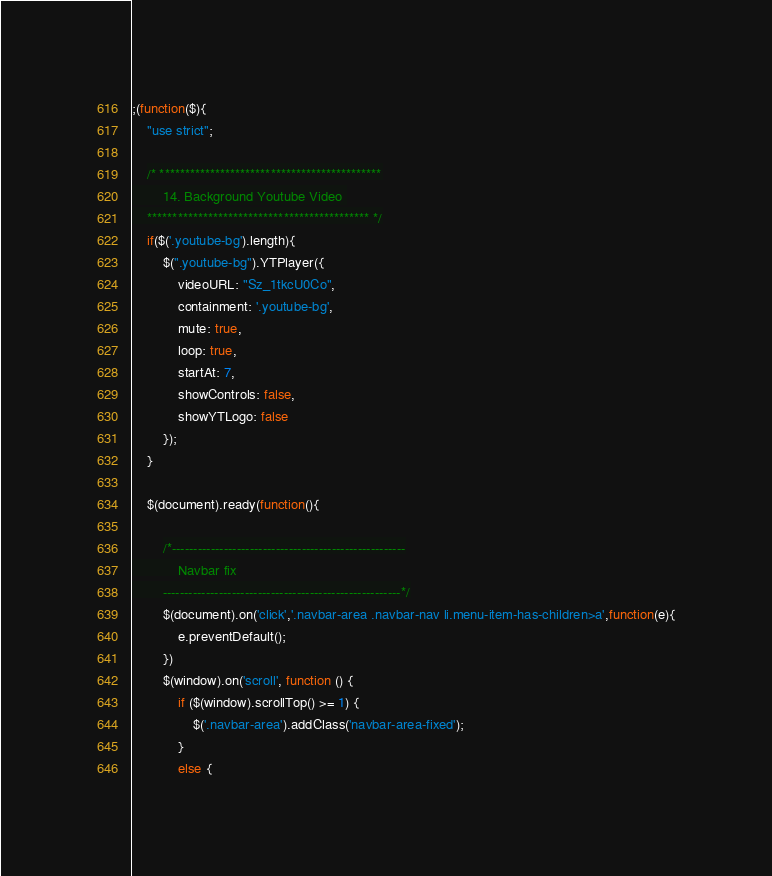Convert code to text. <code><loc_0><loc_0><loc_500><loc_500><_JavaScript_>;(function($){
    "use strict";

    /* ********************************************
        14. Background Youtube Video 
    ******************************************** */
    if($('.youtube-bg').length){
        $(".youtube-bg").YTPlayer({
            videoURL: "Sz_1tkcU0Co",
            containment: '.youtube-bg',
            mute: true,
            loop: true,
            startAt: 7,
            showControls: false,
            showYTLogo: false
        });
    }

    $(document).ready(function(){

        /*------------------------------------------------------
            Navbar fix
        -------------------------------------------------------*/
        $(document).on('click','.navbar-area .navbar-nav li.menu-item-has-children>a',function(e){
            e.preventDefault();
        })
        $(window).on('scroll', function () {
            if ($(window).scrollTop() >= 1) {
                $('.navbar-area').addClass('navbar-area-fixed');
            }
            else {</code> 